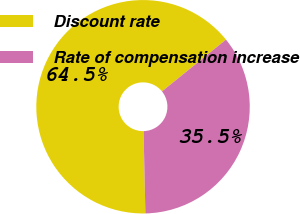Convert chart to OTSL. <chart><loc_0><loc_0><loc_500><loc_500><pie_chart><fcel>Discount rate<fcel>Rate of compensation increase<nl><fcel>64.52%<fcel>35.48%<nl></chart> 